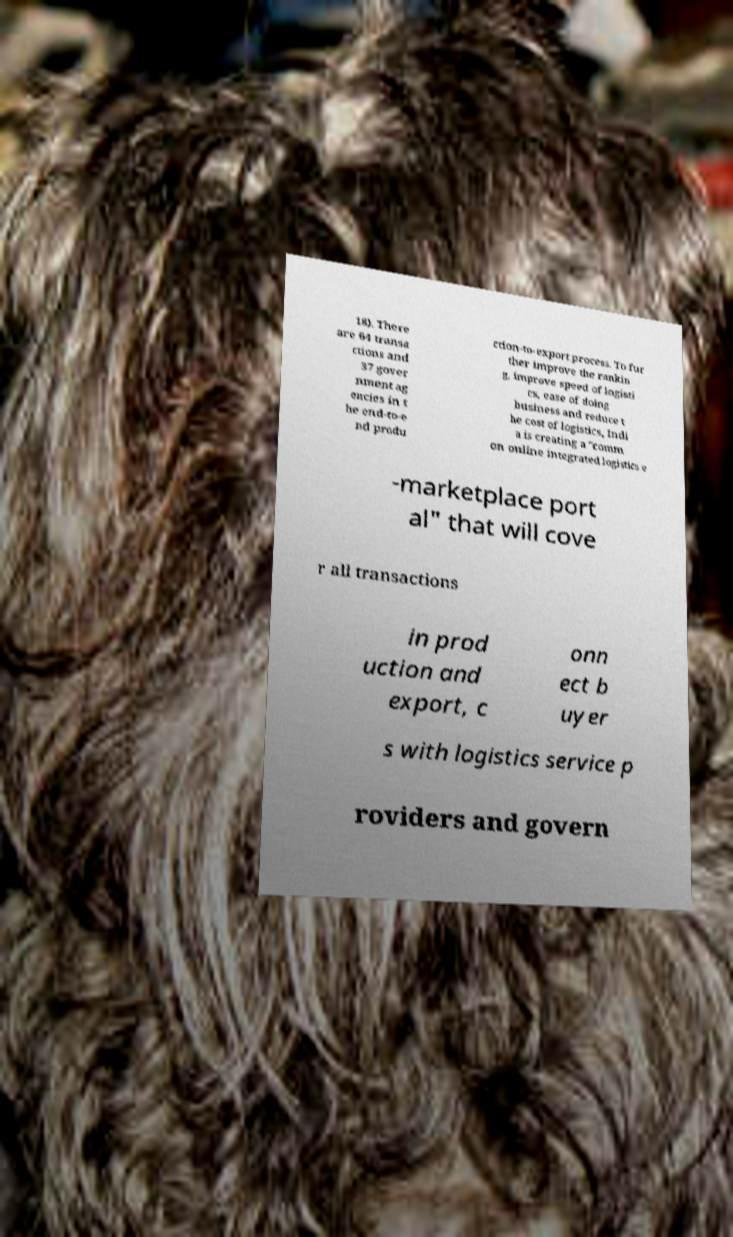For documentation purposes, I need the text within this image transcribed. Could you provide that? 18). There are 64 transa ctions and 37 gover nment ag encies in t he end-to-e nd produ ction-to-export process. To fur ther improve the rankin g, improve speed of logisti cs, ease of doing business and reduce t he cost of logistics, Indi a is creating a "comm on online integrated logistics e -marketplace port al" that will cove r all transactions in prod uction and export, c onn ect b uyer s with logistics service p roviders and govern 